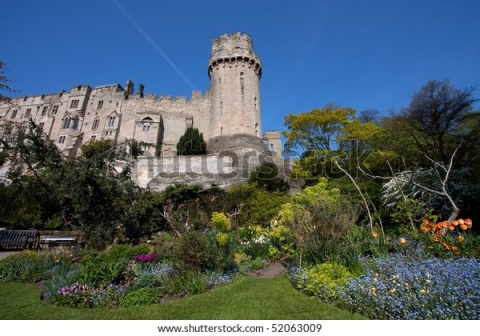Describe the history and possible past occupants of the castle in the image. The castle in the image, with its grand architecture and historic aura, suggests a rich history dating back several centuries. Originally constructed during the medieval period, the castle would have served as both a stronghold and a noble residence. The towering structure indicates it might have been a lookout point, offering strategic advantage against invaders.

Over the centuries, the castle likely housed various nobles and their families, each leaving their mark on its legacy. The gray stone walls have witnessed numerous events, from grand banquets in the great hall to quiet moments of reflection in the elaborate gardens. Occupants might have included medieval knights, noblewomen, and perhaps even royalty. The lush garden surrounding the castle was probably a later addition, reflecting the changing tastes and lifestyles of its inhabitants over time. 